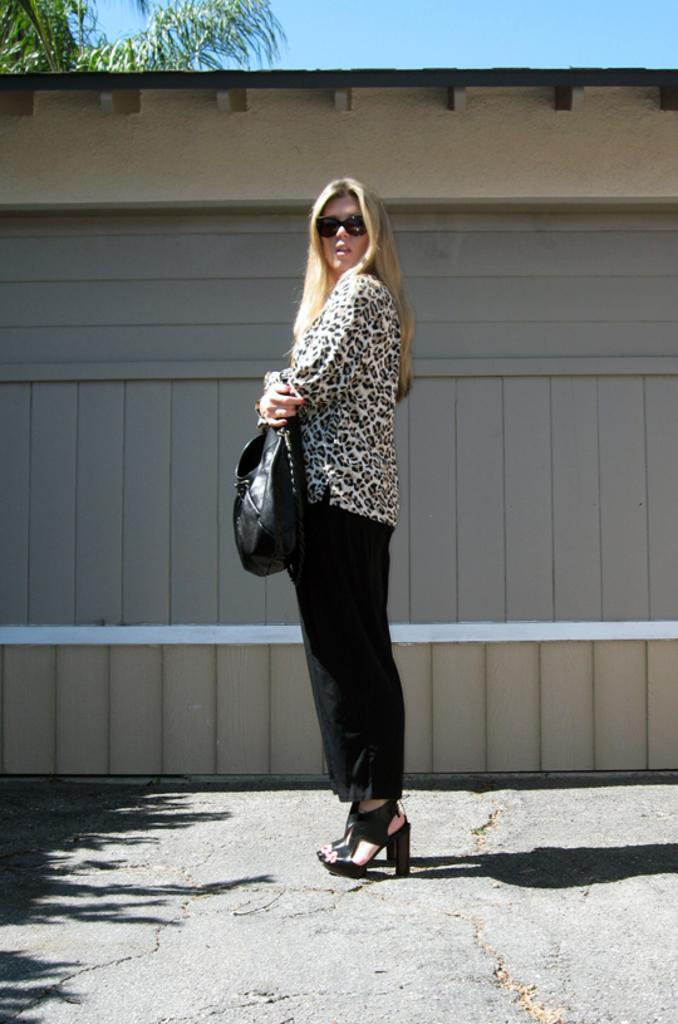Who is present in the image? There is a woman in the image. What is the woman doing in the image? The woman is standing on the road. What is the woman holding in the image? The woman is holding a bag in her hands. What can be seen in the background of the image? There is a shed, sky, and a tree visible in the background of the image. Can you see any wings on the woman in the image? No, there are no wings visible on the woman in the image. What type of cloud can be seen in the image? There is no cloud mentioned or visible in the image; only the sky is mentioned in the background. 